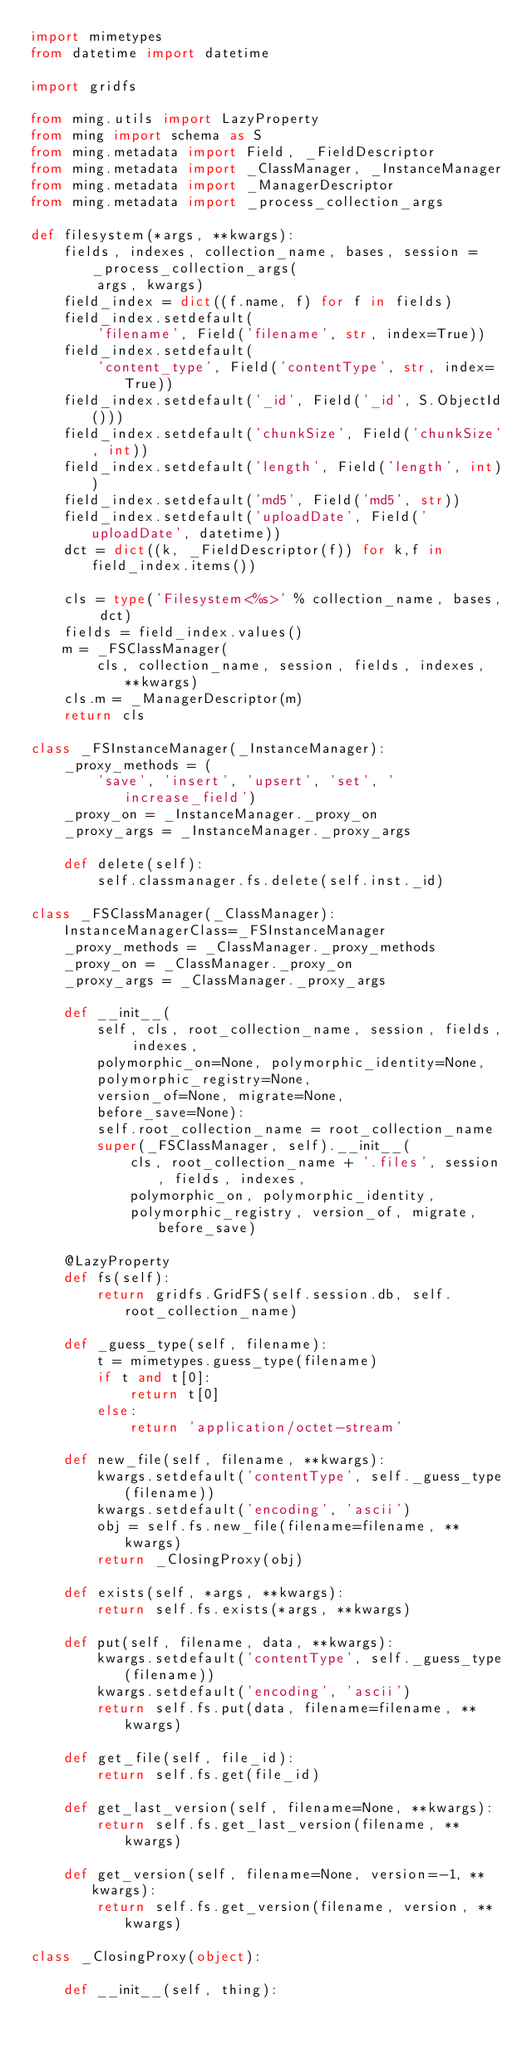Convert code to text. <code><loc_0><loc_0><loc_500><loc_500><_Python_>import mimetypes
from datetime import datetime

import gridfs

from ming.utils import LazyProperty
from ming import schema as S
from ming.metadata import Field, _FieldDescriptor
from ming.metadata import _ClassManager, _InstanceManager
from ming.metadata import _ManagerDescriptor
from ming.metadata import _process_collection_args

def filesystem(*args, **kwargs):
    fields, indexes, collection_name, bases, session = _process_collection_args(
        args, kwargs)
    field_index = dict((f.name, f) for f in fields)
    field_index.setdefault(
        'filename', Field('filename', str, index=True))
    field_index.setdefault(
        'content_type', Field('contentType', str, index=True))
    field_index.setdefault('_id', Field('_id', S.ObjectId()))
    field_index.setdefault('chunkSize', Field('chunkSize', int))
    field_index.setdefault('length', Field('length', int))
    field_index.setdefault('md5', Field('md5', str))
    field_index.setdefault('uploadDate', Field('uploadDate', datetime))
    dct = dict((k, _FieldDescriptor(f)) for k,f in field_index.items())

    cls = type('Filesystem<%s>' % collection_name, bases, dct)
    fields = field_index.values()
    m = _FSClassManager(
        cls, collection_name, session, fields, indexes, **kwargs)
    cls.m = _ManagerDescriptor(m)
    return cls

class _FSInstanceManager(_InstanceManager):
    _proxy_methods = (
        'save', 'insert', 'upsert', 'set', 'increase_field')
    _proxy_on = _InstanceManager._proxy_on
    _proxy_args = _InstanceManager._proxy_args

    def delete(self):
        self.classmanager.fs.delete(self.inst._id)

class _FSClassManager(_ClassManager):
    InstanceManagerClass=_FSInstanceManager
    _proxy_methods = _ClassManager._proxy_methods
    _proxy_on = _ClassManager._proxy_on
    _proxy_args = _ClassManager._proxy_args

    def __init__(
        self, cls, root_collection_name, session, fields, indexes,
        polymorphic_on=None, polymorphic_identity=None,
        polymorphic_registry=None,
        version_of=None, migrate=None,
        before_save=None):
        self.root_collection_name = root_collection_name
        super(_FSClassManager, self).__init__(
            cls, root_collection_name + '.files', session, fields, indexes,
            polymorphic_on, polymorphic_identity,
            polymorphic_registry, version_of, migrate, before_save)

    @LazyProperty
    def fs(self):
        return gridfs.GridFS(self.session.db, self.root_collection_name)

    def _guess_type(self, filename):
        t = mimetypes.guess_type(filename)
        if t and t[0]:
            return t[0]
        else:
            return 'application/octet-stream'

    def new_file(self, filename, **kwargs):
        kwargs.setdefault('contentType', self._guess_type(filename))
        kwargs.setdefault('encoding', 'ascii')
        obj = self.fs.new_file(filename=filename, **kwargs)
        return _ClosingProxy(obj)

    def exists(self, *args, **kwargs):
        return self.fs.exists(*args, **kwargs)

    def put(self, filename, data, **kwargs):
        kwargs.setdefault('contentType', self._guess_type(filename))
        kwargs.setdefault('encoding', 'ascii')
        return self.fs.put(data, filename=filename, **kwargs)

    def get_file(self, file_id):
        return self.fs.get(file_id)

    def get_last_version(self, filename=None, **kwargs):
        return self.fs.get_last_version(filename, **kwargs)

    def get_version(self, filename=None, version=-1, **kwargs):
        return self.fs.get_version(filename, version, **kwargs)

class _ClosingProxy(object):

    def __init__(self, thing):</code> 